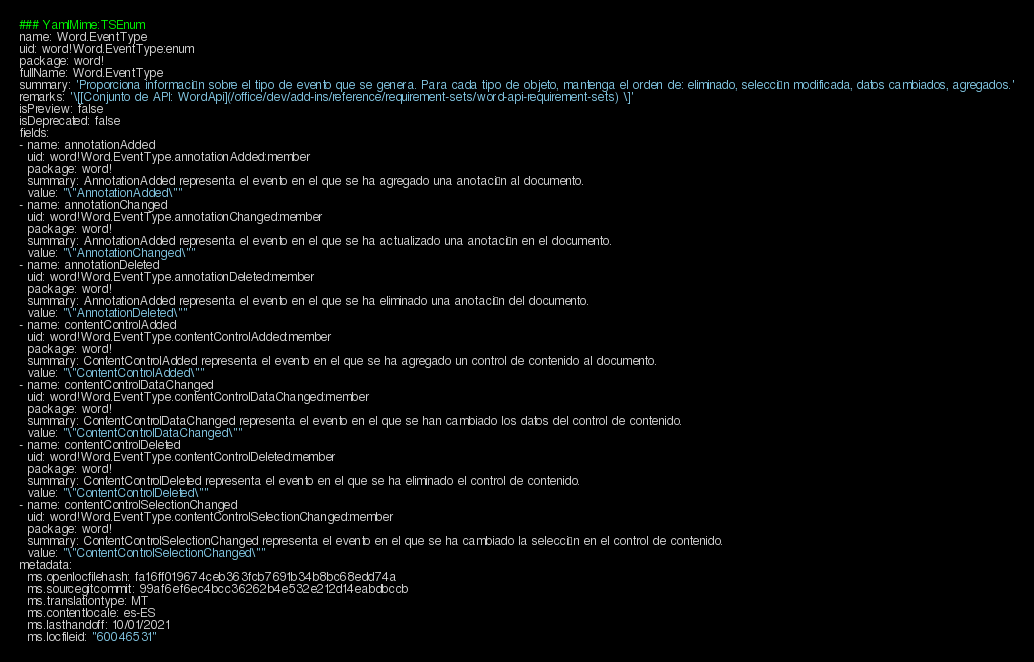Convert code to text. <code><loc_0><loc_0><loc_500><loc_500><_YAML_>### YamlMime:TSEnum
name: Word.EventType
uid: word!Word.EventType:enum
package: word!
fullName: Word.EventType
summary: 'Proporciona información sobre el tipo de evento que se genera. Para cada tipo de objeto, mantenga el orden de: eliminado, selección modificada, datos cambiados, agregados.'
remarks: '\[[Conjunto de API: WordApi](/office/dev/add-ins/reference/requirement-sets/word-api-requirement-sets) \]'
isPreview: false
isDeprecated: false
fields:
- name: annotationAdded
  uid: word!Word.EventType.annotationAdded:member
  package: word!
  summary: AnnotationAdded representa el evento en el que se ha agregado una anotación al documento.
  value: "\"AnnotationAdded\""
- name: annotationChanged
  uid: word!Word.EventType.annotationChanged:member
  package: word!
  summary: AnnotationAdded representa el evento en el que se ha actualizado una anotación en el documento.
  value: "\"AnnotationChanged\""
- name: annotationDeleted
  uid: word!Word.EventType.annotationDeleted:member
  package: word!
  summary: AnnotationAdded representa el evento en el que se ha eliminado una anotación del documento.
  value: "\"AnnotationDeleted\""
- name: contentControlAdded
  uid: word!Word.EventType.contentControlAdded:member
  package: word!
  summary: ContentControlAdded representa el evento en el que se ha agregado un control de contenido al documento.
  value: "\"ContentControlAdded\""
- name: contentControlDataChanged
  uid: word!Word.EventType.contentControlDataChanged:member
  package: word!
  summary: ContentControlDataChanged representa el evento en el que se han cambiado los datos del control de contenido.
  value: "\"ContentControlDataChanged\""
- name: contentControlDeleted
  uid: word!Word.EventType.contentControlDeleted:member
  package: word!
  summary: ContentControlDeleted representa el evento en el que se ha eliminado el control de contenido.
  value: "\"ContentControlDeleted\""
- name: contentControlSelectionChanged
  uid: word!Word.EventType.contentControlSelectionChanged:member
  package: word!
  summary: ContentControlSelectionChanged representa el evento en el que se ha cambiado la selección en el control de contenido.
  value: "\"ContentControlSelectionChanged\""
metadata:
  ms.openlocfilehash: fa16ff019674ceb363fcb7691b34b8bc68edd74a
  ms.sourcegitcommit: 99af6ef6ec4bcc36262b4e532e212d14eabdbccb
  ms.translationtype: MT
  ms.contentlocale: es-ES
  ms.lasthandoff: 10/01/2021
  ms.locfileid: "60046531"
</code> 